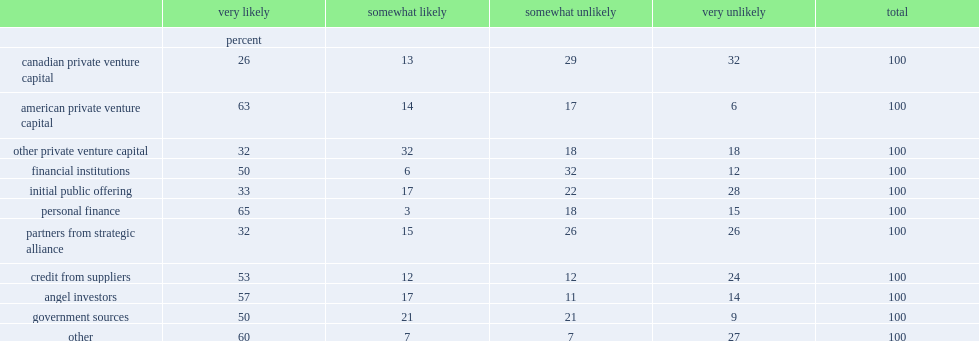Which were the top three most frequently-mentioned sources of potential new capital among all the capital sources? Personal finance american private venture capital angel investors. 